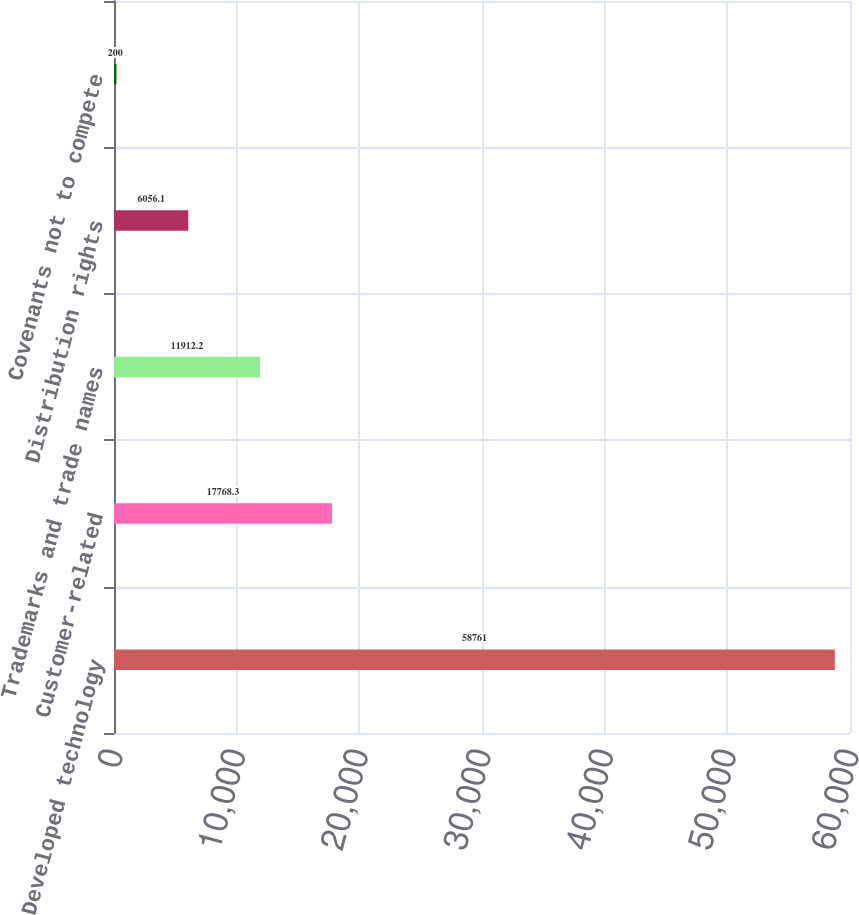Convert chart to OTSL. <chart><loc_0><loc_0><loc_500><loc_500><bar_chart><fcel>Developed technology<fcel>Customer-related<fcel>Trademarks and trade names<fcel>Distribution rights<fcel>Covenants not to compete<nl><fcel>58761<fcel>17768.3<fcel>11912.2<fcel>6056.1<fcel>200<nl></chart> 